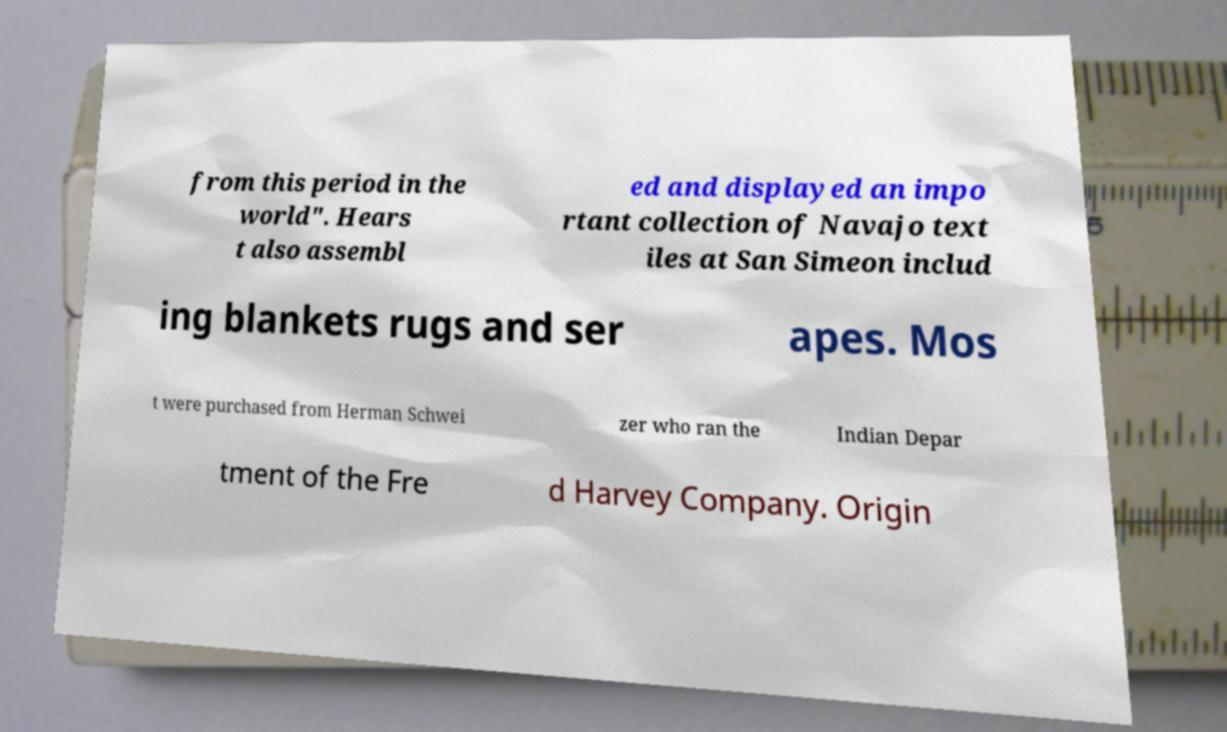Could you extract and type out the text from this image? from this period in the world". Hears t also assembl ed and displayed an impo rtant collection of Navajo text iles at San Simeon includ ing blankets rugs and ser apes. Mos t were purchased from Herman Schwei zer who ran the Indian Depar tment of the Fre d Harvey Company. Origin 